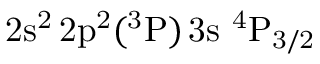Convert formula to latex. <formula><loc_0><loc_0><loc_500><loc_500>2 s ^ { 2 } \, 2 p ^ { 2 } ( ^ { 3 } P ) \, 3 s ^ { 4 } P _ { 3 / 2 }</formula> 